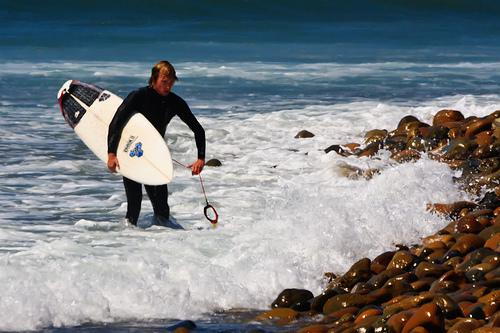Question: how is the water?
Choices:
A. Very choppy.
B. Calm.
C. Smooth.
D. Salty.
Answer with the letter. Answer: A Question: what is the man holding?
Choices:
A. A burger.
B. Hotdog.
C. A surfboard.
D. Sandwich.
Answer with the letter. Answer: C Question: what color are the rocks?
Choices:
A. Grey.
B. Mostly brown.
C. Completely brown.
D. Reddish-brown.
Answer with the letter. Answer: B Question: what is the man doing?
Choices:
A. Laughing.
B. Joking.
C. Surfing.
D. Skiing.
Answer with the letter. Answer: C 